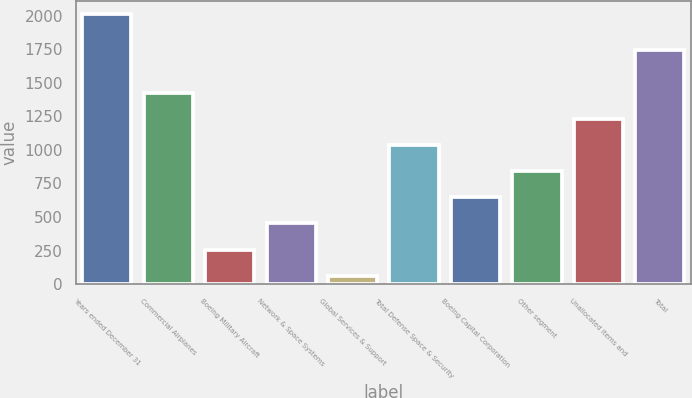Convert chart to OTSL. <chart><loc_0><loc_0><loc_500><loc_500><bar_chart><fcel>Years ended December 31<fcel>Commercial Airplanes<fcel>Boeing Military Aircraft<fcel>Network & Space Systems<fcel>Global Services & Support<fcel>Total Defense Space & Security<fcel>Boeing Capital Corporation<fcel>Other segment<fcel>Unallocated items and<fcel>Total<nl><fcel>2010<fcel>1425.9<fcel>257.7<fcel>452.4<fcel>63<fcel>1036.5<fcel>647.1<fcel>841.8<fcel>1231.2<fcel>1746<nl></chart> 